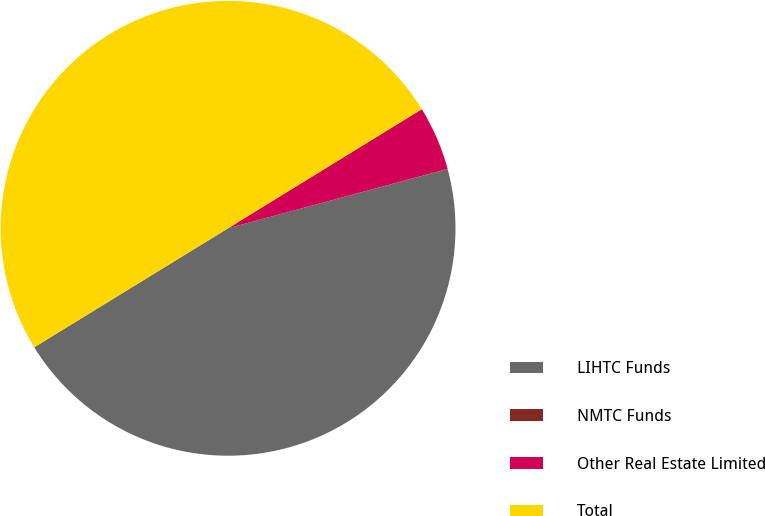Convert chart to OTSL. <chart><loc_0><loc_0><loc_500><loc_500><pie_chart><fcel>LIHTC Funds<fcel>NMTC Funds<fcel>Other Real Estate Limited<fcel>Total<nl><fcel>45.43%<fcel>0.01%<fcel>4.57%<fcel>49.99%<nl></chart> 